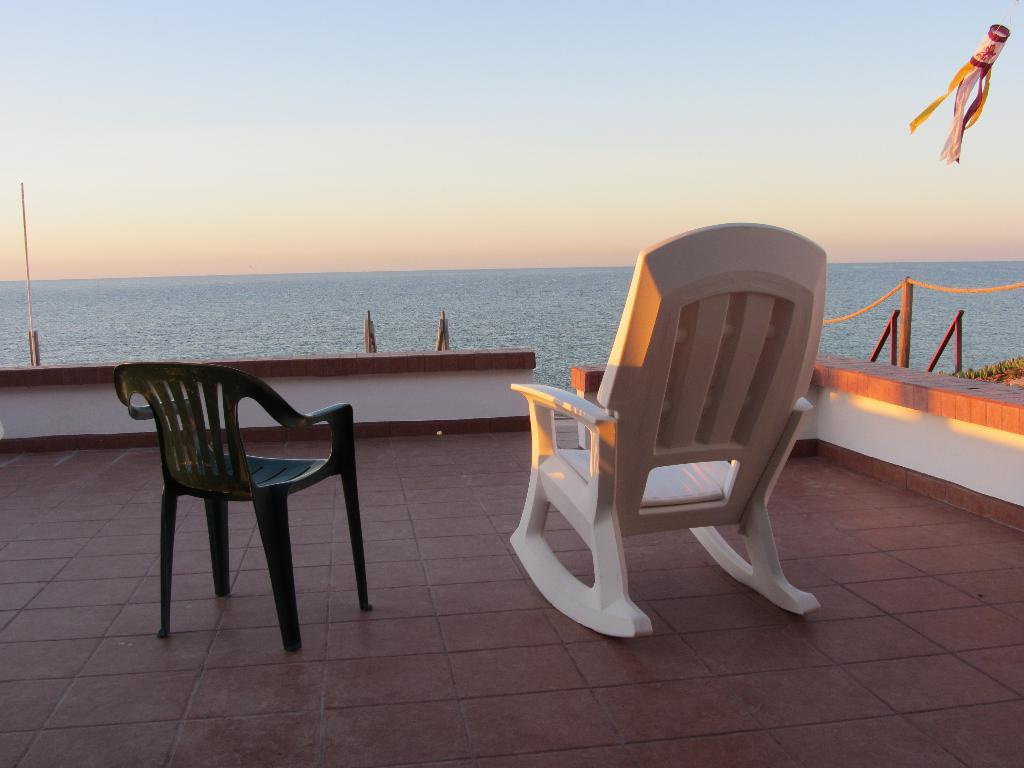How many chairs are in the image? There are two chairs in the image. Where are the chairs located? The chairs are on the floor. What can be seen in the background of the image? Water and the clear sky are visible in the background of the image. What appliance is causing the water to rise in the image? There is no appliance present in the image, and the water level does not appear to be rising. 